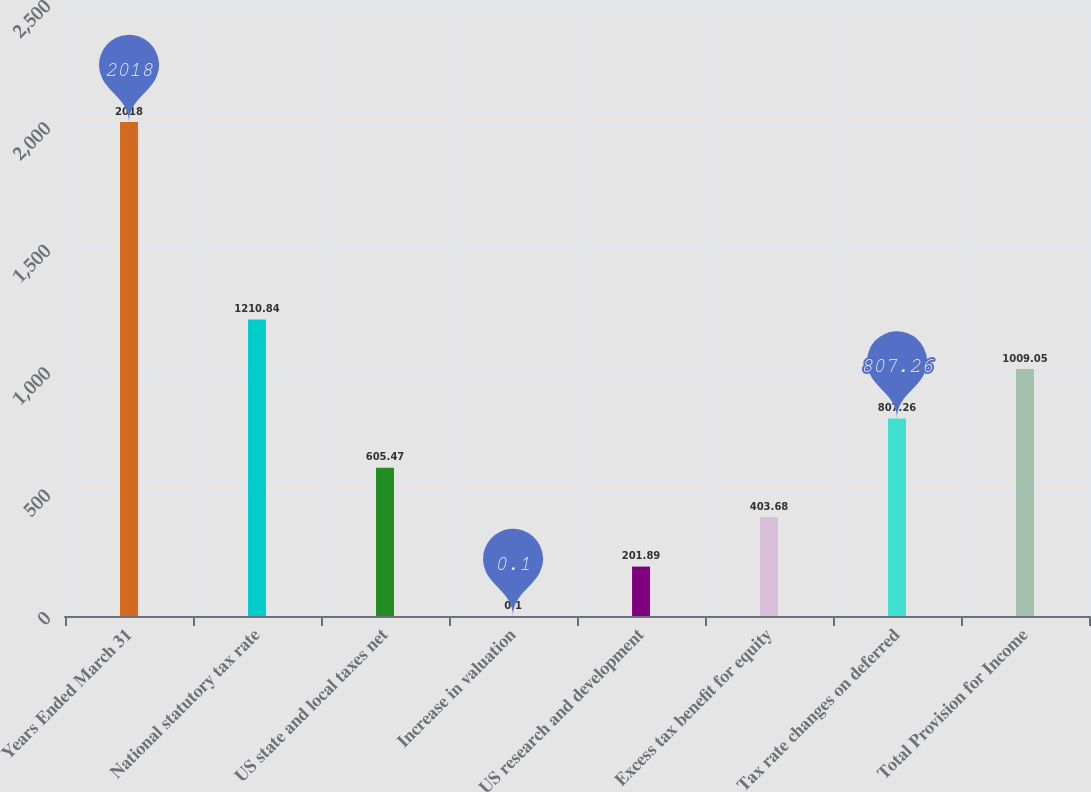<chart> <loc_0><loc_0><loc_500><loc_500><bar_chart><fcel>Years Ended March 31<fcel>National statutory tax rate<fcel>US state and local taxes net<fcel>Increase in valuation<fcel>US research and development<fcel>Excess tax benefit for equity<fcel>Tax rate changes on deferred<fcel>Total Provision for Income<nl><fcel>2018<fcel>1210.84<fcel>605.47<fcel>0.1<fcel>201.89<fcel>403.68<fcel>807.26<fcel>1009.05<nl></chart> 